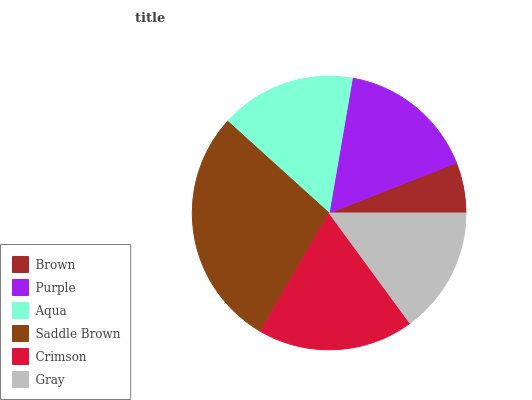Is Brown the minimum?
Answer yes or no. Yes. Is Saddle Brown the maximum?
Answer yes or no. Yes. Is Purple the minimum?
Answer yes or no. No. Is Purple the maximum?
Answer yes or no. No. Is Purple greater than Brown?
Answer yes or no. Yes. Is Brown less than Purple?
Answer yes or no. Yes. Is Brown greater than Purple?
Answer yes or no. No. Is Purple less than Brown?
Answer yes or no. No. Is Purple the high median?
Answer yes or no. Yes. Is Aqua the low median?
Answer yes or no. Yes. Is Aqua the high median?
Answer yes or no. No. Is Brown the low median?
Answer yes or no. No. 